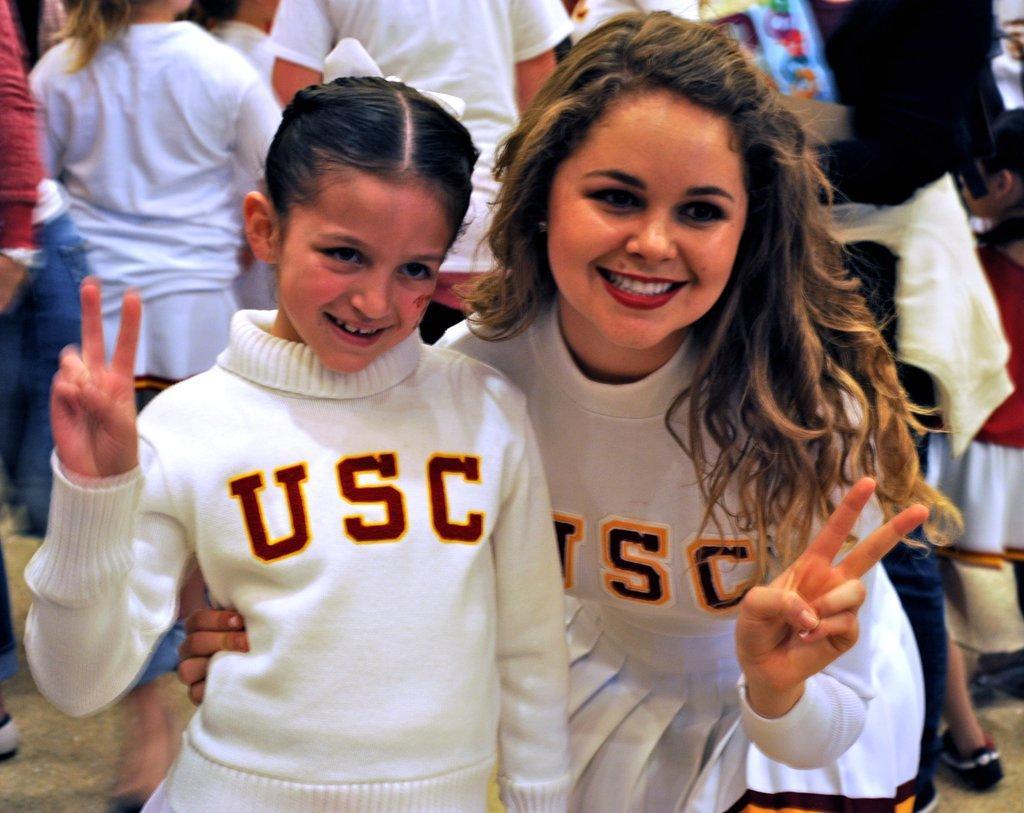How would you summarize this image in a sentence or two? In this image I can see a woman and a girl they both are wearing a white color t-shirt and they are smiling background I can see persons 